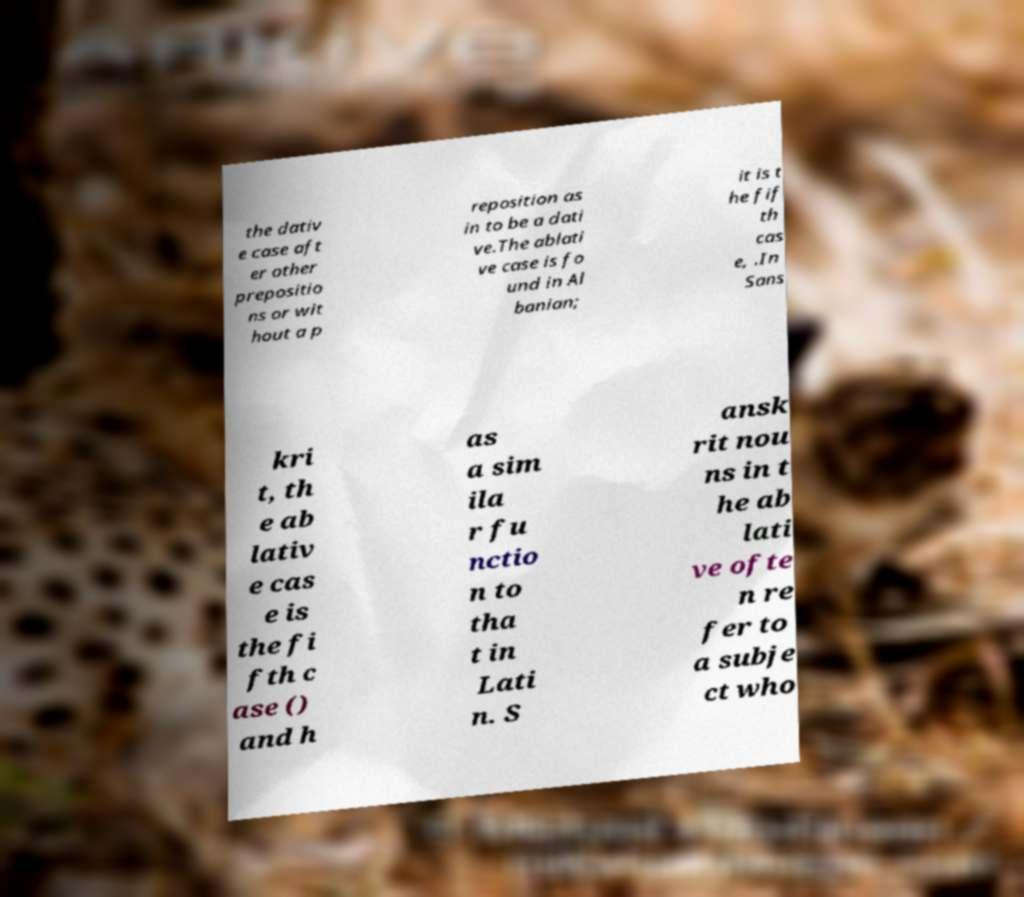Please read and relay the text visible in this image. What does it say? the dativ e case aft er other prepositio ns or wit hout a p reposition as in to be a dati ve.The ablati ve case is fo und in Al banian; it is t he fif th cas e, .In Sans kri t, th e ab lativ e cas e is the fi fth c ase () and h as a sim ila r fu nctio n to tha t in Lati n. S ansk rit nou ns in t he ab lati ve ofte n re fer to a subje ct who 